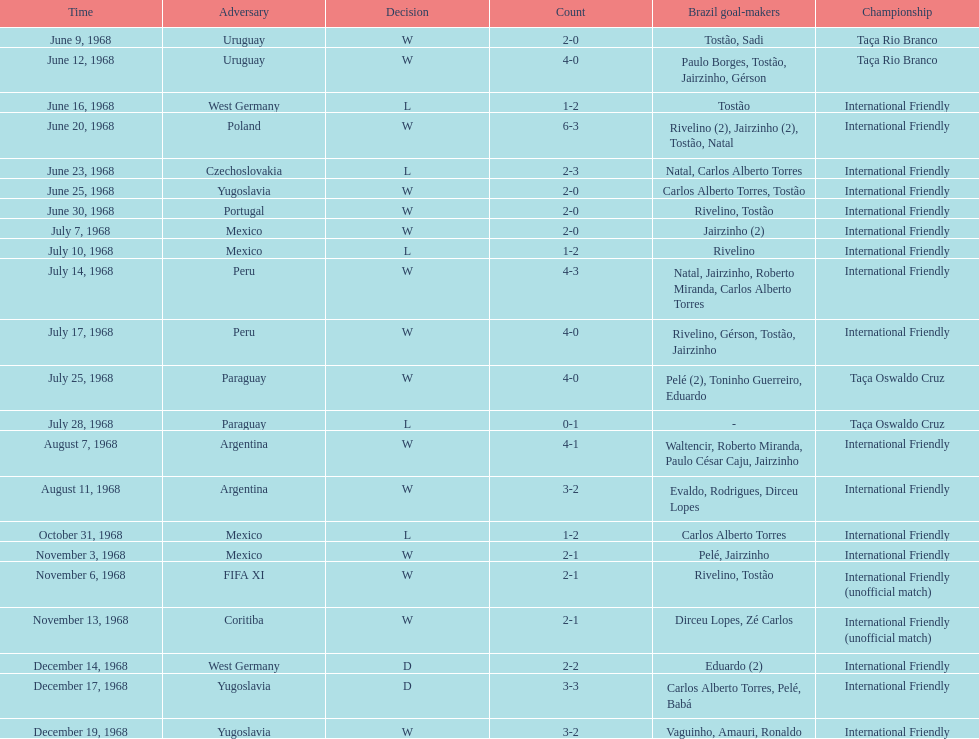Give me the full table as a dictionary. {'header': ['Time', 'Adversary', 'Decision', 'Count', 'Brazil goal-makers', 'Championship'], 'rows': [['June 9, 1968', 'Uruguay', 'W', '2-0', 'Tostão, Sadi', 'Taça Rio Branco'], ['June 12, 1968', 'Uruguay', 'W', '4-0', 'Paulo Borges, Tostão, Jairzinho, Gérson', 'Taça Rio Branco'], ['June 16, 1968', 'West Germany', 'L', '1-2', 'Tostão', 'International Friendly'], ['June 20, 1968', 'Poland', 'W', '6-3', 'Rivelino (2), Jairzinho (2), Tostão, Natal', 'International Friendly'], ['June 23, 1968', 'Czechoslovakia', 'L', '2-3', 'Natal, Carlos Alberto Torres', 'International Friendly'], ['June 25, 1968', 'Yugoslavia', 'W', '2-0', 'Carlos Alberto Torres, Tostão', 'International Friendly'], ['June 30, 1968', 'Portugal', 'W', '2-0', 'Rivelino, Tostão', 'International Friendly'], ['July 7, 1968', 'Mexico', 'W', '2-0', 'Jairzinho (2)', 'International Friendly'], ['July 10, 1968', 'Mexico', 'L', '1-2', 'Rivelino', 'International Friendly'], ['July 14, 1968', 'Peru', 'W', '4-3', 'Natal, Jairzinho, Roberto Miranda, Carlos Alberto Torres', 'International Friendly'], ['July 17, 1968', 'Peru', 'W', '4-0', 'Rivelino, Gérson, Tostão, Jairzinho', 'International Friendly'], ['July 25, 1968', 'Paraguay', 'W', '4-0', 'Pelé (2), Toninho Guerreiro, Eduardo', 'Taça Oswaldo Cruz'], ['July 28, 1968', 'Paraguay', 'L', '0-1', '-', 'Taça Oswaldo Cruz'], ['August 7, 1968', 'Argentina', 'W', '4-1', 'Waltencir, Roberto Miranda, Paulo César Caju, Jairzinho', 'International Friendly'], ['August 11, 1968', 'Argentina', 'W', '3-2', 'Evaldo, Rodrigues, Dirceu Lopes', 'International Friendly'], ['October 31, 1968', 'Mexico', 'L', '1-2', 'Carlos Alberto Torres', 'International Friendly'], ['November 3, 1968', 'Mexico', 'W', '2-1', 'Pelé, Jairzinho', 'International Friendly'], ['November 6, 1968', 'FIFA XI', 'W', '2-1', 'Rivelino, Tostão', 'International Friendly (unofficial match)'], ['November 13, 1968', 'Coritiba', 'W', '2-1', 'Dirceu Lopes, Zé Carlos', 'International Friendly (unofficial match)'], ['December 14, 1968', 'West Germany', 'D', '2-2', 'Eduardo (2)', 'International Friendly'], ['December 17, 1968', 'Yugoslavia', 'D', '3-3', 'Carlos Alberto Torres, Pelé, Babá', 'International Friendly'], ['December 19, 1968', 'Yugoslavia', 'W', '3-2', 'Vaguinho, Amauri, Ronaldo', 'International Friendly']]} The most goals scored by brazil in a game 6. 